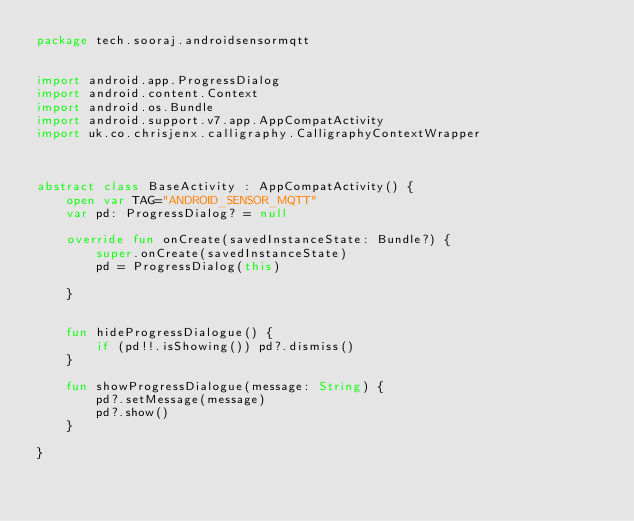Convert code to text. <code><loc_0><loc_0><loc_500><loc_500><_Kotlin_>package tech.sooraj.androidsensormqtt


import android.app.ProgressDialog
import android.content.Context
import android.os.Bundle
import android.support.v7.app.AppCompatActivity
import uk.co.chrisjenx.calligraphy.CalligraphyContextWrapper



abstract class BaseActivity : AppCompatActivity() {
    open var TAG="ANDROID_SENSOR_MQTT"
    var pd: ProgressDialog? = null

    override fun onCreate(savedInstanceState: Bundle?) {
        super.onCreate(savedInstanceState)
        pd = ProgressDialog(this)

    }


    fun hideProgressDialogue() {
        if (pd!!.isShowing()) pd?.dismiss()
    }

    fun showProgressDialogue(message: String) {
        pd?.setMessage(message)
        pd?.show()
    }

}</code> 